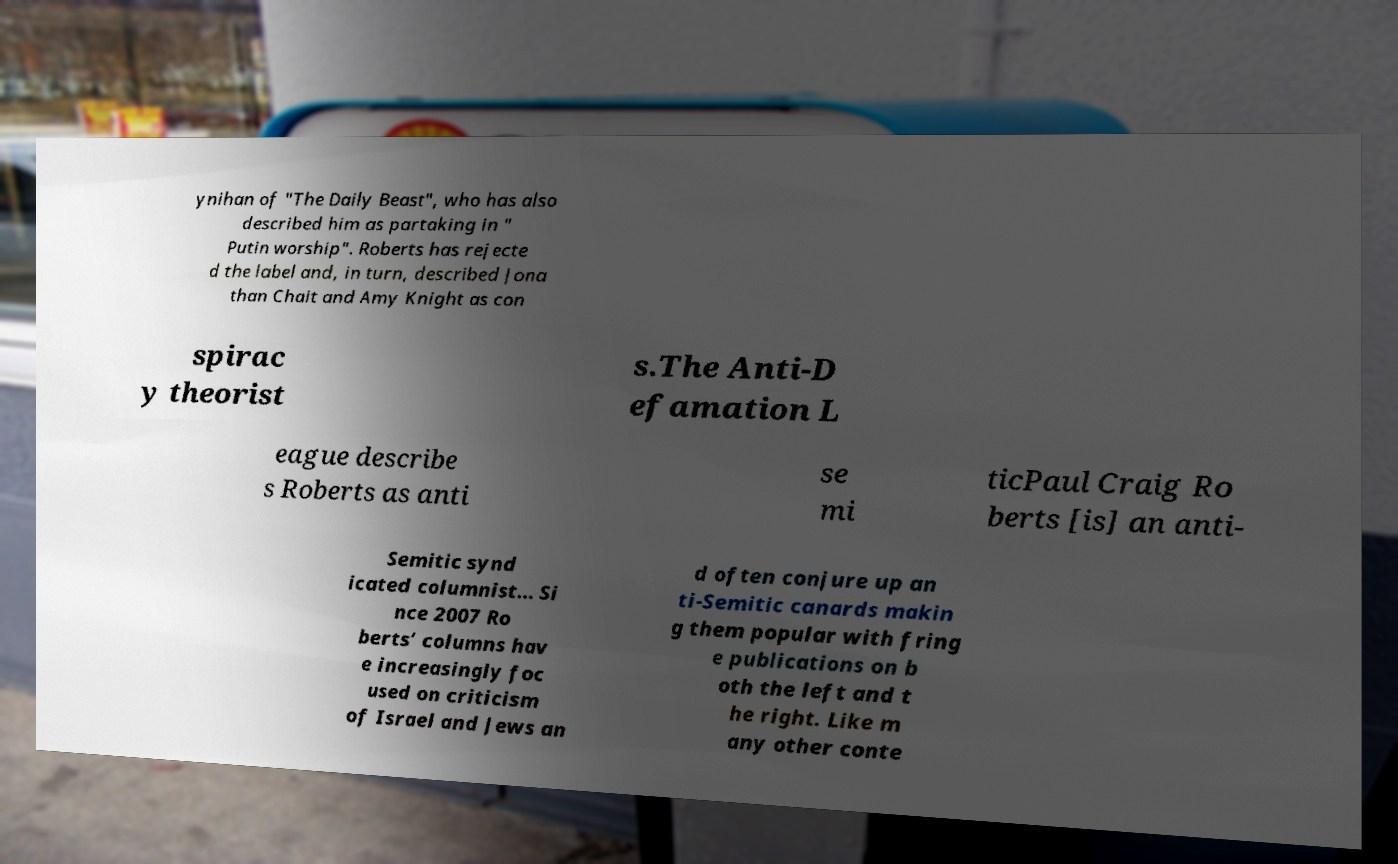Please identify and transcribe the text found in this image. ynihan of "The Daily Beast", who has also described him as partaking in " Putin worship". Roberts has rejecte d the label and, in turn, described Jona than Chait and Amy Knight as con spirac y theorist s.The Anti-D efamation L eague describe s Roberts as anti se mi ticPaul Craig Ro berts [is] an anti- Semitic synd icated columnist... Si nce 2007 Ro berts’ columns hav e increasingly foc used on criticism of Israel and Jews an d often conjure up an ti-Semitic canards makin g them popular with fring e publications on b oth the left and t he right. Like m any other conte 